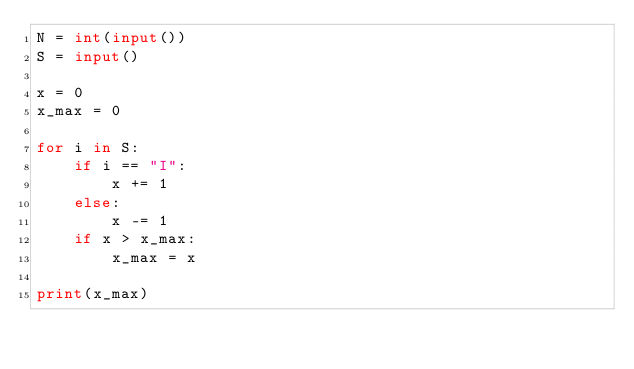<code> <loc_0><loc_0><loc_500><loc_500><_Python_>N = int(input())
S = input()

x = 0
x_max = 0

for i in S:
    if i == "I":
        x += 1
    else:
        x -= 1
    if x > x_max:
        x_max = x

print(x_max)</code> 